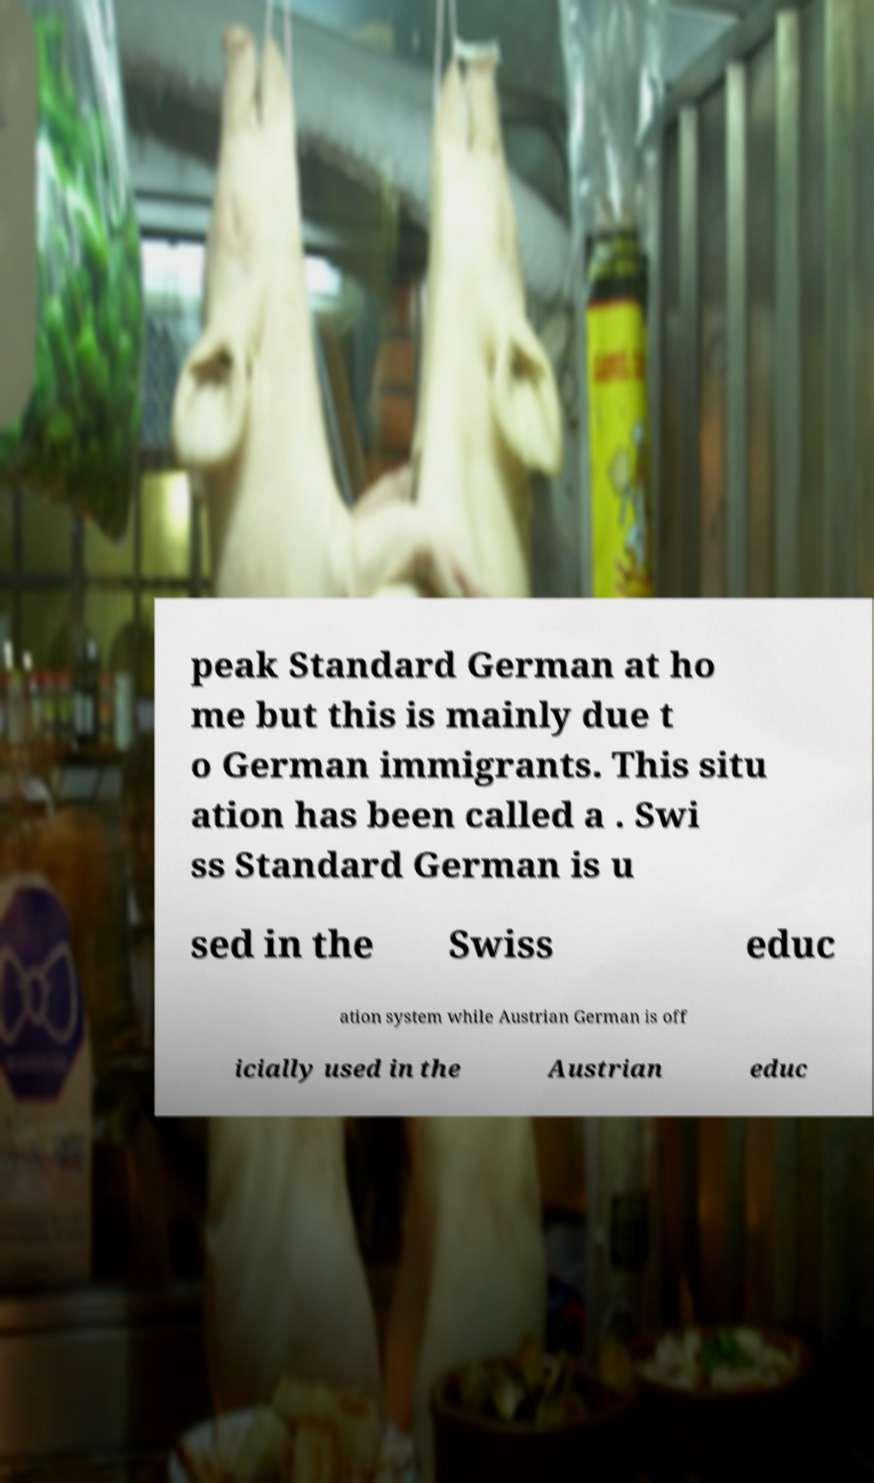Please read and relay the text visible in this image. What does it say? peak Standard German at ho me but this is mainly due t o German immigrants. This situ ation has been called a . Swi ss Standard German is u sed in the Swiss educ ation system while Austrian German is off icially used in the Austrian educ 